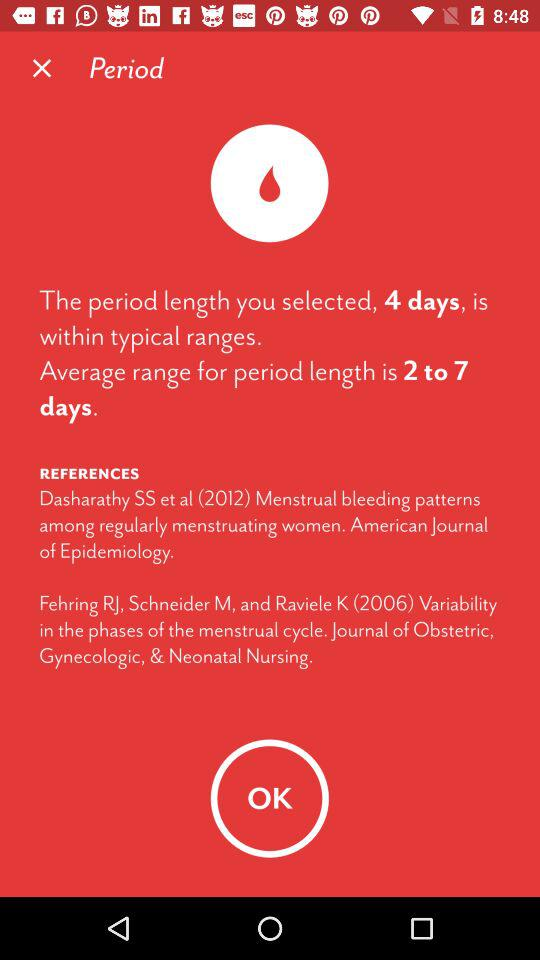What is the length of the period selected? The length of the period is 2 to 7 days. 